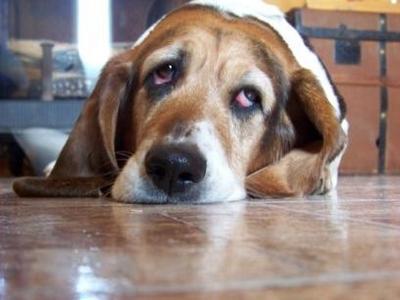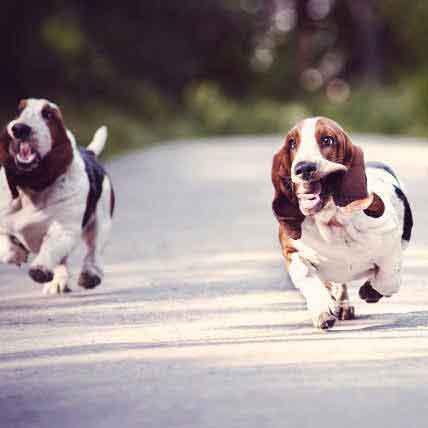The first image is the image on the left, the second image is the image on the right. Evaluate the accuracy of this statement regarding the images: "There are dogs running on pavement.". Is it true? Answer yes or no. Yes. 